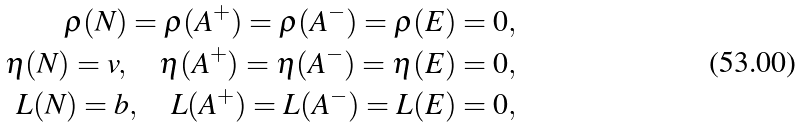<formula> <loc_0><loc_0><loc_500><loc_500>\rho ( N ) = \rho ( A ^ { + } ) = \rho ( A ^ { - } ) = \rho ( E ) = 0 , \\ \eta ( N ) = v , \quad \eta ( A ^ { + } ) = \eta ( A ^ { - } ) = \eta ( E ) = 0 , \\ L ( N ) = b , \quad L ( A ^ { + } ) = L ( A ^ { - } ) = L ( E ) = 0 ,</formula> 